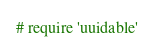<code> <loc_0><loc_0><loc_500><loc_500><_Ruby_># require 'uuidable'
</code> 